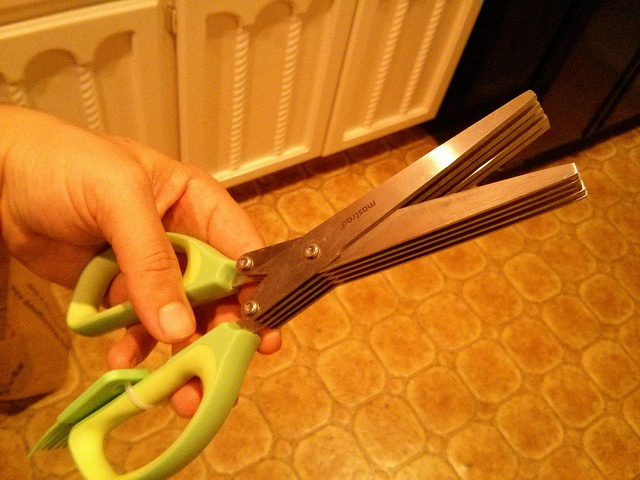Describe the objects in this image and their specific colors. I can see scissors in orange, brown, and maroon tones and people in orange, red, and maroon tones in this image. 